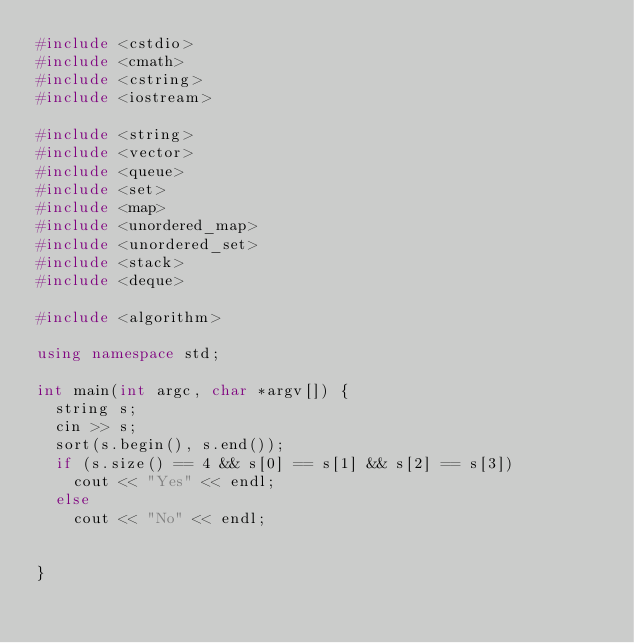Convert code to text. <code><loc_0><loc_0><loc_500><loc_500><_C++_>#include <cstdio>
#include <cmath>
#include <cstring>
#include <iostream>

#include <string>
#include <vector>
#include <queue>
#include <set>
#include <map>
#include <unordered_map>
#include <unordered_set>
#include <stack>
#include <deque>

#include <algorithm>

using namespace std;

int main(int argc, char *argv[]) {
	string s;
	cin >> s;
	sort(s.begin(), s.end());
	if (s.size() == 4 && s[0] == s[1] && s[2] == s[3])
		cout << "Yes" << endl;
	else
		cout << "No" << endl;	


}












</code> 